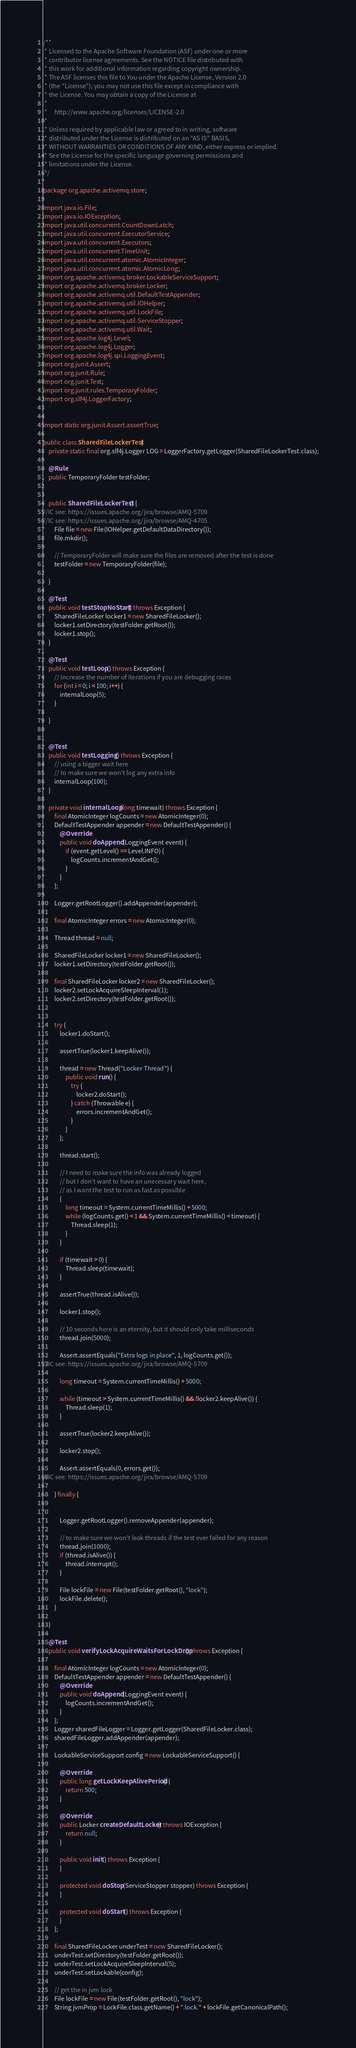<code> <loc_0><loc_0><loc_500><loc_500><_Java_>/**
 * Licensed to the Apache Software Foundation (ASF) under one or more
 * contributor license agreements. See the NOTICE file distributed with
 * this work for additional information regarding copyright ownership.
 * The ASF licenses this file to You under the Apache License, Version 2.0
 * (the "License"); you may not use this file except in compliance with
 * the License. You may obtain a copy of the License at
 *
 *     http://www.apache.org/licenses/LICENSE-2.0
 *
 * Unless required by applicable law or agreed to in writing, software
 * distributed under the License is distributed on an "AS IS" BASIS,
 * WITHOUT WARRANTIES OR CONDITIONS OF ANY KIND, either express or implied.
 * See the License for the specific language governing permissions and
 * limitations under the License.
 */

package org.apache.activemq.store;

import java.io.File;
import java.io.IOException;
import java.util.concurrent.CountDownLatch;
import java.util.concurrent.ExecutorService;
import java.util.concurrent.Executors;
import java.util.concurrent.TimeUnit;
import java.util.concurrent.atomic.AtomicInteger;
import java.util.concurrent.atomic.AtomicLong;
import org.apache.activemq.broker.LockableServiceSupport;
import org.apache.activemq.broker.Locker;
import org.apache.activemq.util.DefaultTestAppender;
import org.apache.activemq.util.IOHelper;
import org.apache.activemq.util.LockFile;
import org.apache.activemq.util.ServiceStopper;
import org.apache.activemq.util.Wait;
import org.apache.log4j.Level;
import org.apache.log4j.Logger;
import org.apache.log4j.spi.LoggingEvent;
import org.junit.Assert;
import org.junit.Rule;
import org.junit.Test;
import org.junit.rules.TemporaryFolder;
import org.slf4j.LoggerFactory;


import static org.junit.Assert.assertTrue;

public class SharedFileLockerTest {
    private static final org.slf4j.Logger LOG = LoggerFactory.getLogger(SharedFileLockerTest.class);

    @Rule
    public TemporaryFolder testFolder;


    public SharedFileLockerTest() {
//IC see: https://issues.apache.org/jira/browse/AMQ-5709
//IC see: https://issues.apache.org/jira/browse/AMQ-4705
        File file = new File(IOHelper.getDefaultDataDirectory());
        file.mkdir();

        // TemporaryFolder will make sure the files are removed after the test is done
        testFolder = new TemporaryFolder(file);

    }

    @Test
    public void testStopNoStart() throws Exception {
        SharedFileLocker locker1 = new SharedFileLocker();
        locker1.setDirectory(testFolder.getRoot());
        locker1.stop();
    }

    @Test
    public void testLoop() throws Exception {
        // Increase the number of iterations if you are debugging races
        for (int i = 0; i < 100; i++) {
            internalLoop(5);
        }

    }


    @Test
    public void testLogging() throws Exception {
        // using a bigger wait here
        // to make sure we won't log any extra info
        internalLoop(100);
    }

    private void internalLoop(long timewait) throws Exception {
        final AtomicInteger logCounts = new AtomicInteger(0);
        DefaultTestAppender appender = new DefaultTestAppender() {
            @Override
            public void doAppend(LoggingEvent event) {
                if (event.getLevel() == Level.INFO) {
                    logCounts.incrementAndGet();
                }
            }
        };

        Logger.getRootLogger().addAppender(appender);

        final AtomicInteger errors = new AtomicInteger(0);

        Thread thread = null;

        SharedFileLocker locker1 = new SharedFileLocker();
        locker1.setDirectory(testFolder.getRoot());

        final SharedFileLocker locker2 = new SharedFileLocker();
        locker2.setLockAcquireSleepInterval(1);
        locker2.setDirectory(testFolder.getRoot());


        try {
            locker1.doStart();

            assertTrue(locker1.keepAlive());

            thread = new Thread("Locker Thread") {
                public void run() {
                    try {
                        locker2.doStart();
                    } catch (Throwable e) {
                        errors.incrementAndGet();
                    }
                }
            };

            thread.start();

            // I need to make sure the info was already logged
            // but I don't want to have an unecessary wait here,
            // as I want the test to run as fast as possible
            {
                long timeout = System.currentTimeMillis() + 5000;
                while (logCounts.get() < 1 && System.currentTimeMillis() < timeout) {
                    Thread.sleep(1);
                }
            }

            if (timewait > 0) {
                Thread.sleep(timewait);
            }

            assertTrue(thread.isAlive());

            locker1.stop();

            // 10 seconds here is an eternity, but it should only take milliseconds
            thread.join(5000);

            Assert.assertEquals("Extra logs in place", 1, logCounts.get());
//IC see: https://issues.apache.org/jira/browse/AMQ-5709

            long timeout = System.currentTimeMillis() + 5000;

            while (timeout > System.currentTimeMillis() && !locker2.keepAlive()) {
                Thread.sleep(1);
            }

            assertTrue(locker2.keepAlive());

            locker2.stop();

            Assert.assertEquals(0, errors.get());
//IC see: https://issues.apache.org/jira/browse/AMQ-5709

        } finally {


            Logger.getRootLogger().removeAppender(appender);

            // to make sure we won't leak threads if the test ever failed for any reason
            thread.join(1000);
            if (thread.isAlive()) {
                thread.interrupt();
            }

            File lockFile = new File(testFolder.getRoot(), "lock");
            lockFile.delete();
        }

    }

    @Test
    public void verifyLockAcquireWaitsForLockDrop() throws Exception {

        final AtomicInteger logCounts = new AtomicInteger(0);
        DefaultTestAppender appender = new DefaultTestAppender() {
            @Override
            public void doAppend(LoggingEvent event) {
                logCounts.incrementAndGet();
            }
        };
        Logger sharedFileLogger = Logger.getLogger(SharedFileLocker.class);
        sharedFileLogger.addAppender(appender);

        LockableServiceSupport config = new LockableServiceSupport() {

            @Override
            public long getLockKeepAlivePeriod() {
                return 500;
            }

            @Override
            public Locker createDefaultLocker() throws IOException {
                return null;
            }

            public void init() throws Exception {
            }

            protected void doStop(ServiceStopper stopper) throws Exception {
            }

            protected void doStart() throws Exception {
            }
        };

        final SharedFileLocker underTest = new SharedFileLocker();
        underTest.setDirectory(testFolder.getRoot());
        underTest.setLockAcquireSleepInterval(5);
        underTest.setLockable(config);

        // get the in jvm lock
        File lockFile = new File(testFolder.getRoot(), "lock");
        String jvmProp = LockFile.class.getName() + ".lock." + lockFile.getCanonicalPath();</code> 